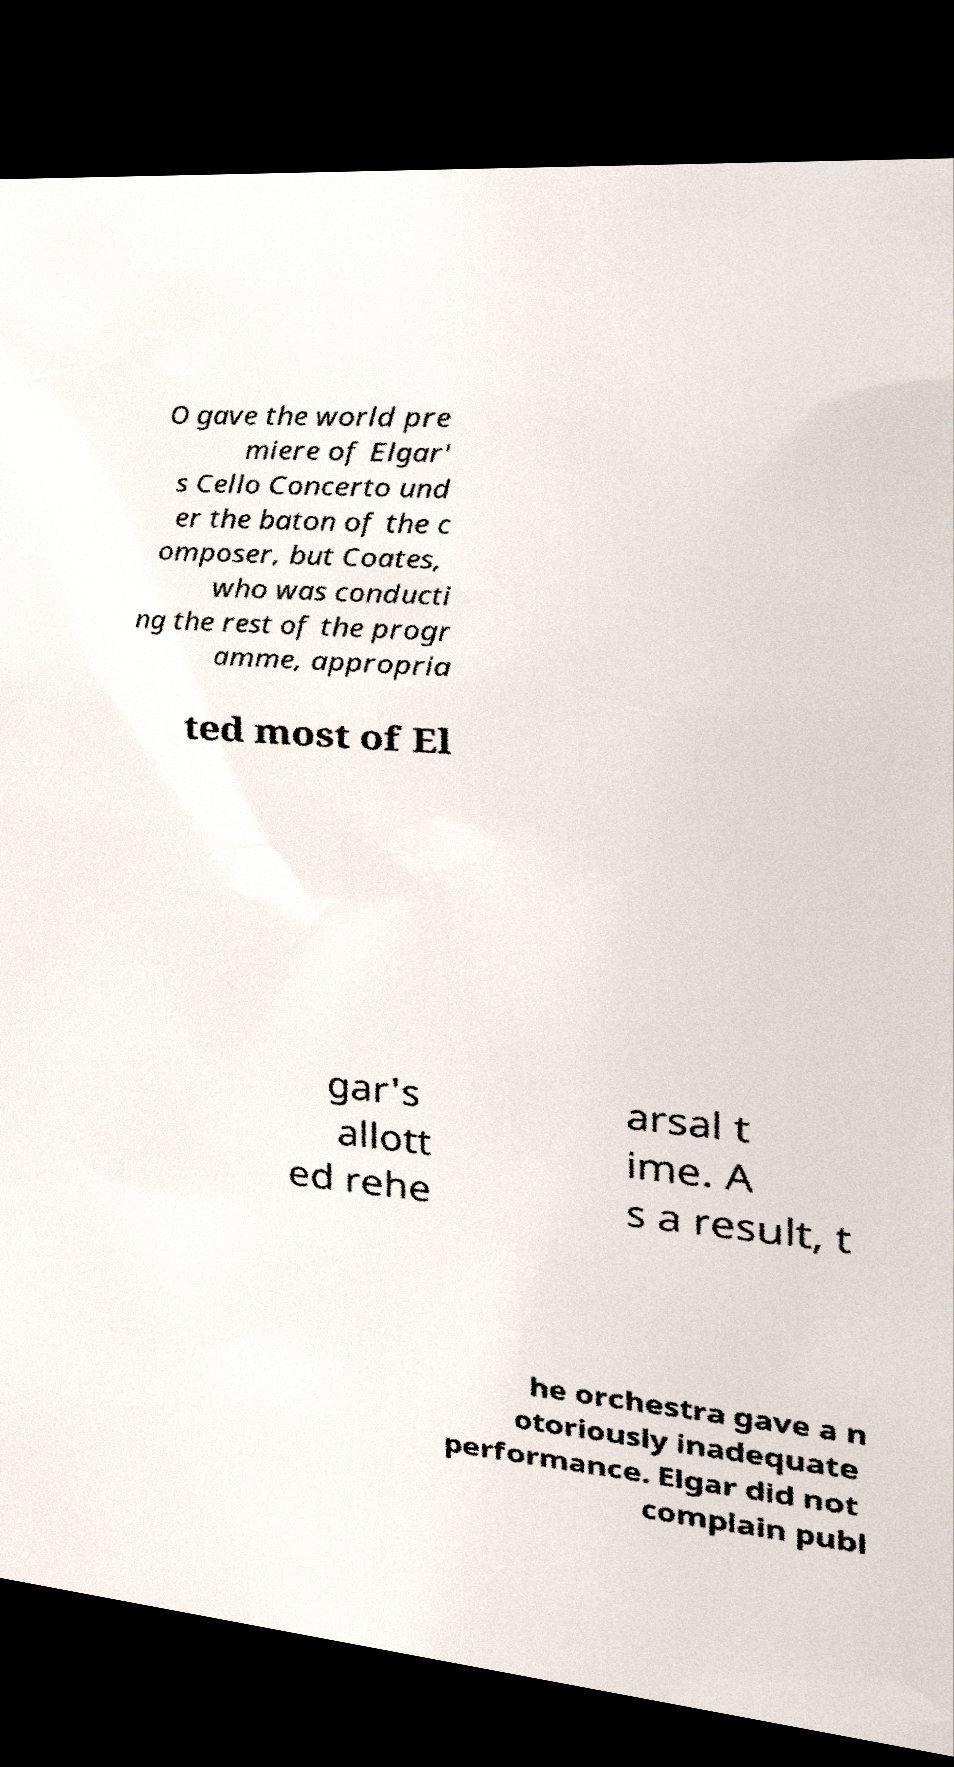Can you accurately transcribe the text from the provided image for me? O gave the world pre miere of Elgar' s Cello Concerto und er the baton of the c omposer, but Coates, who was conducti ng the rest of the progr amme, appropria ted most of El gar's allott ed rehe arsal t ime. A s a result, t he orchestra gave a n otoriously inadequate performance. Elgar did not complain publ 